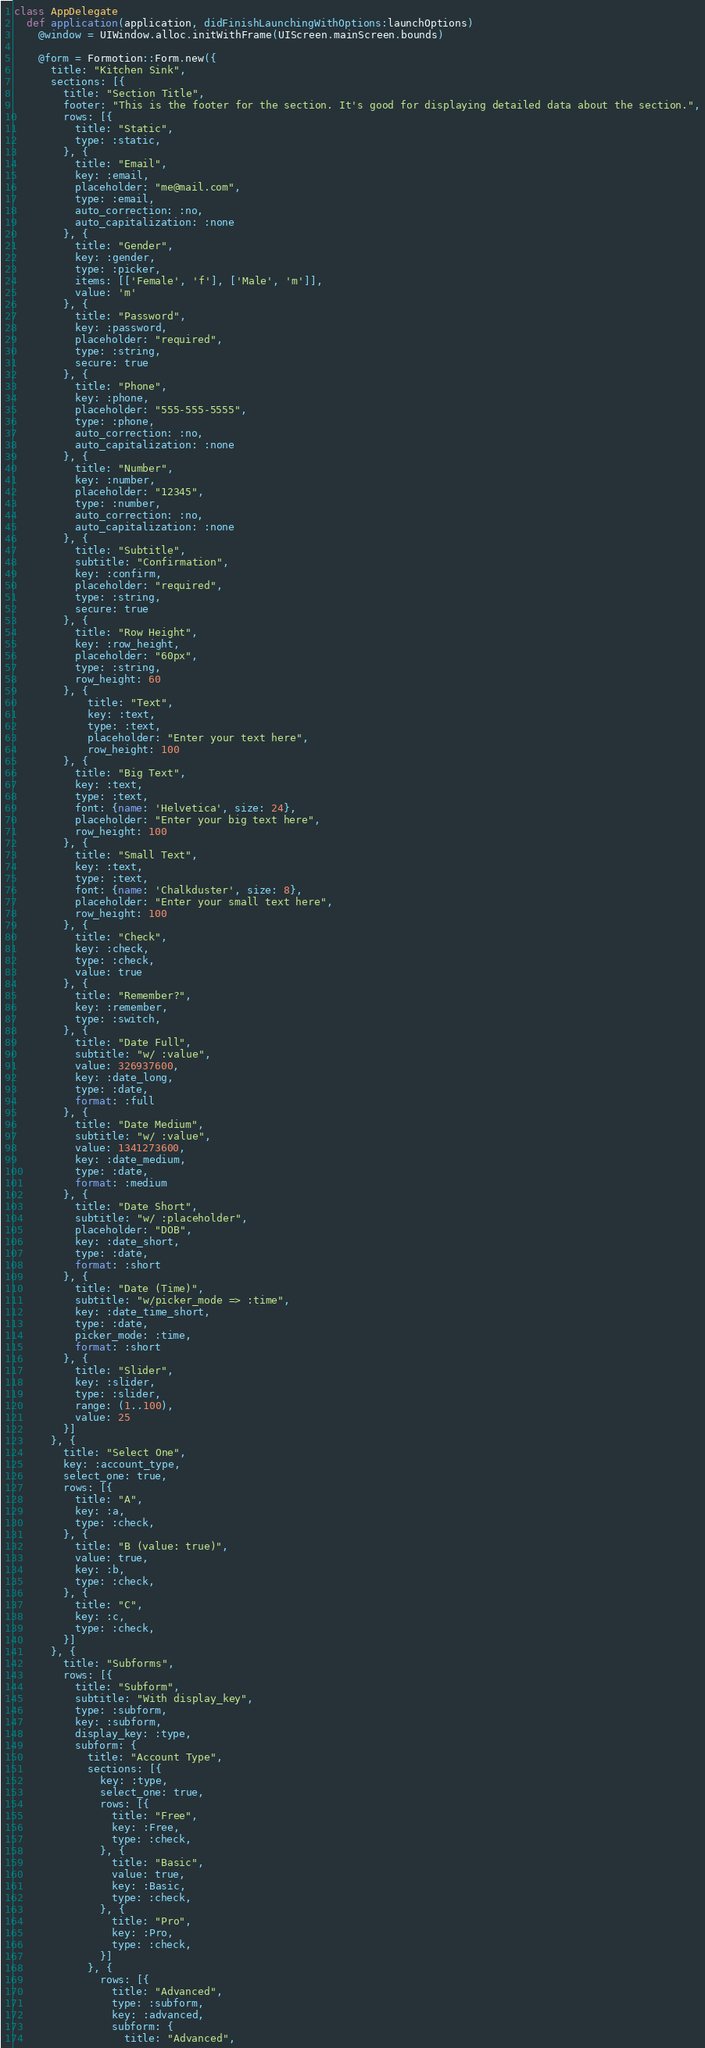Convert code to text. <code><loc_0><loc_0><loc_500><loc_500><_Ruby_>class AppDelegate
  def application(application, didFinishLaunchingWithOptions:launchOptions)
    @window = UIWindow.alloc.initWithFrame(UIScreen.mainScreen.bounds)

    @form = Formotion::Form.new({
      title: "Kitchen Sink",
      sections: [{
        title: "Section Title",
        footer: "This is the footer for the section. It's good for displaying detailed data about the section.",
        rows: [{
          title: "Static",
          type: :static,
        }, {
          title: "Email",
          key: :email,
          placeholder: "me@mail.com",
          type: :email,
          auto_correction: :no,
          auto_capitalization: :none
        }, {
          title: "Gender",
          key: :gender,
          type: :picker,
          items: [['Female', 'f'], ['Male', 'm']],
          value: 'm'
        }, {
          title: "Password",
          key: :password,
          placeholder: "required",
          type: :string,
          secure: true
        }, {
          title: "Phone",
          key: :phone,
          placeholder: "555-555-5555",
          type: :phone,
          auto_correction: :no,
          auto_capitalization: :none
        }, {
          title: "Number",
          key: :number,
          placeholder: "12345",
          type: :number,
          auto_correction: :no,
          auto_capitalization: :none
        }, {
          title: "Subtitle",
          subtitle: "Confirmation",
          key: :confirm,
          placeholder: "required",
          type: :string,
          secure: true
        }, {
          title: "Row Height",
          key: :row_height,
          placeholder: "60px",
          type: :string,
          row_height: 60
        }, {
            title: "Text",
            key: :text,
            type: :text,
            placeholder: "Enter your text here",
            row_height: 100
        }, {
          title: "Big Text",
          key: :text,
          type: :text,
          font: {name: 'Helvetica', size: 24},
          placeholder: "Enter your big text here",
          row_height: 100
        }, {
          title: "Small Text",
          key: :text,
          type: :text,
          font: {name: 'Chalkduster', size: 8},
          placeholder: "Enter your small text here",
          row_height: 100
        }, {
          title: "Check",
          key: :check,
          type: :check,
          value: true
        }, {
          title: "Remember?",
          key: :remember,
          type: :switch,
        }, {
          title: "Date Full",
          subtitle: "w/ :value",
          value: 326937600,
          key: :date_long,
          type: :date,
          format: :full
        }, {
          title: "Date Medium",
          subtitle: "w/ :value",
          value: 1341273600,
          key: :date_medium,
          type: :date,
          format: :medium
        }, {
          title: "Date Short",
          subtitle: "w/ :placeholder",
          placeholder: "DOB",
          key: :date_short,
          type: :date,
          format: :short
        }, {
          title: "Date (Time)",
          subtitle: "w/picker_mode => :time",
          key: :date_time_short,
          type: :date,
          picker_mode: :time,
          format: :short
        }, {
          title: "Slider",
          key: :slider,
          type: :slider,
          range: (1..100),
          value: 25
        }]
      }, {
        title: "Select One",
        key: :account_type,
        select_one: true,
        rows: [{
          title: "A",
          key: :a,
          type: :check,
        }, {
          title: "B (value: true)",
          value: true,
          key: :b,
          type: :check,
        }, {
          title: "C",
          key: :c,
          type: :check,
        }]
      }, {
        title: "Subforms",
        rows: [{
          title: "Subform",
          subtitle: "With display_key",
          type: :subform,
          key: :subform,
          display_key: :type,
          subform: {
            title: "Account Type",
            sections: [{
              key: :type,
              select_one: true,
              rows: [{
                title: "Free",
                key: :Free,
                type: :check,
              }, {
                title: "Basic",
                value: true,
                key: :Basic,
                type: :check,
              }, {
                title: "Pro",
                key: :Pro,
                type: :check,
              }]
            }, {
              rows: [{
                title: "Advanced",
                type: :subform,
                key: :advanced,
                subform: {
                  title: "Advanced",</code> 